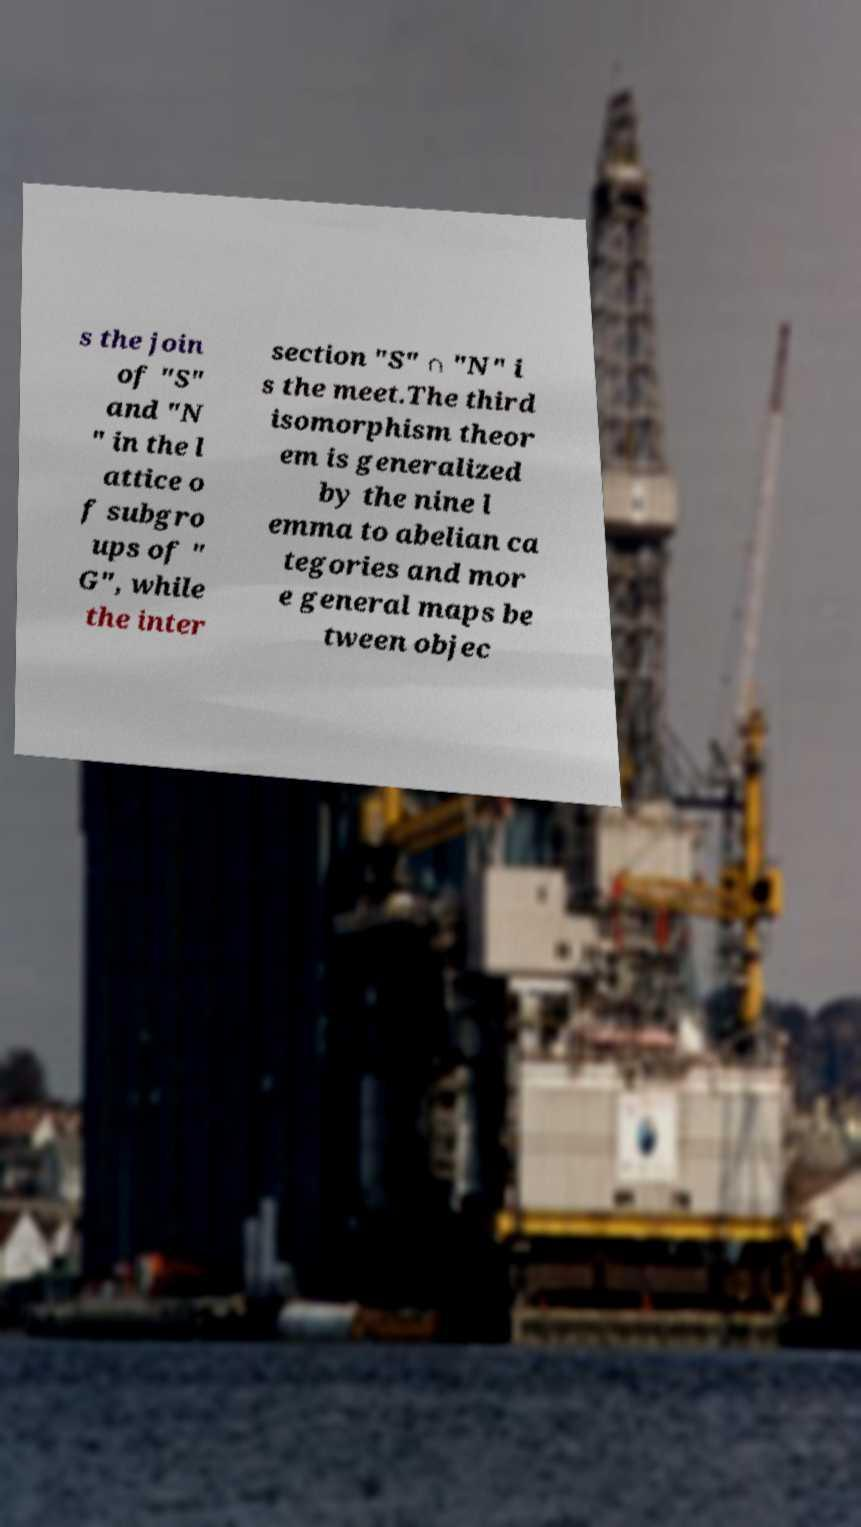Could you assist in decoding the text presented in this image and type it out clearly? s the join of "S" and "N " in the l attice o f subgro ups of " G", while the inter section "S" ∩ "N" i s the meet.The third isomorphism theor em is generalized by the nine l emma to abelian ca tegories and mor e general maps be tween objec 